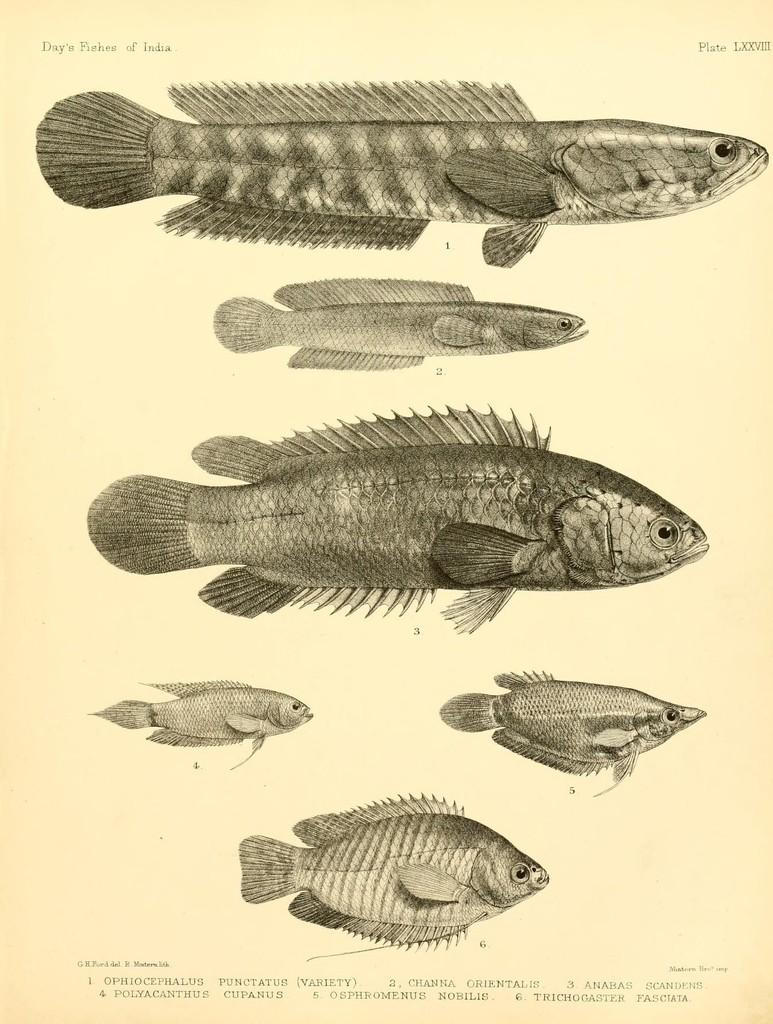What is depicted on the paper in the image? There are pictures of fish on the paper. What else can be found on the paper besides the pictures of fish? There is text on the paper. What songs is the queen singing in the image? There is no queen or songs present in the image; it only features pictures of fish and text on a paper. 